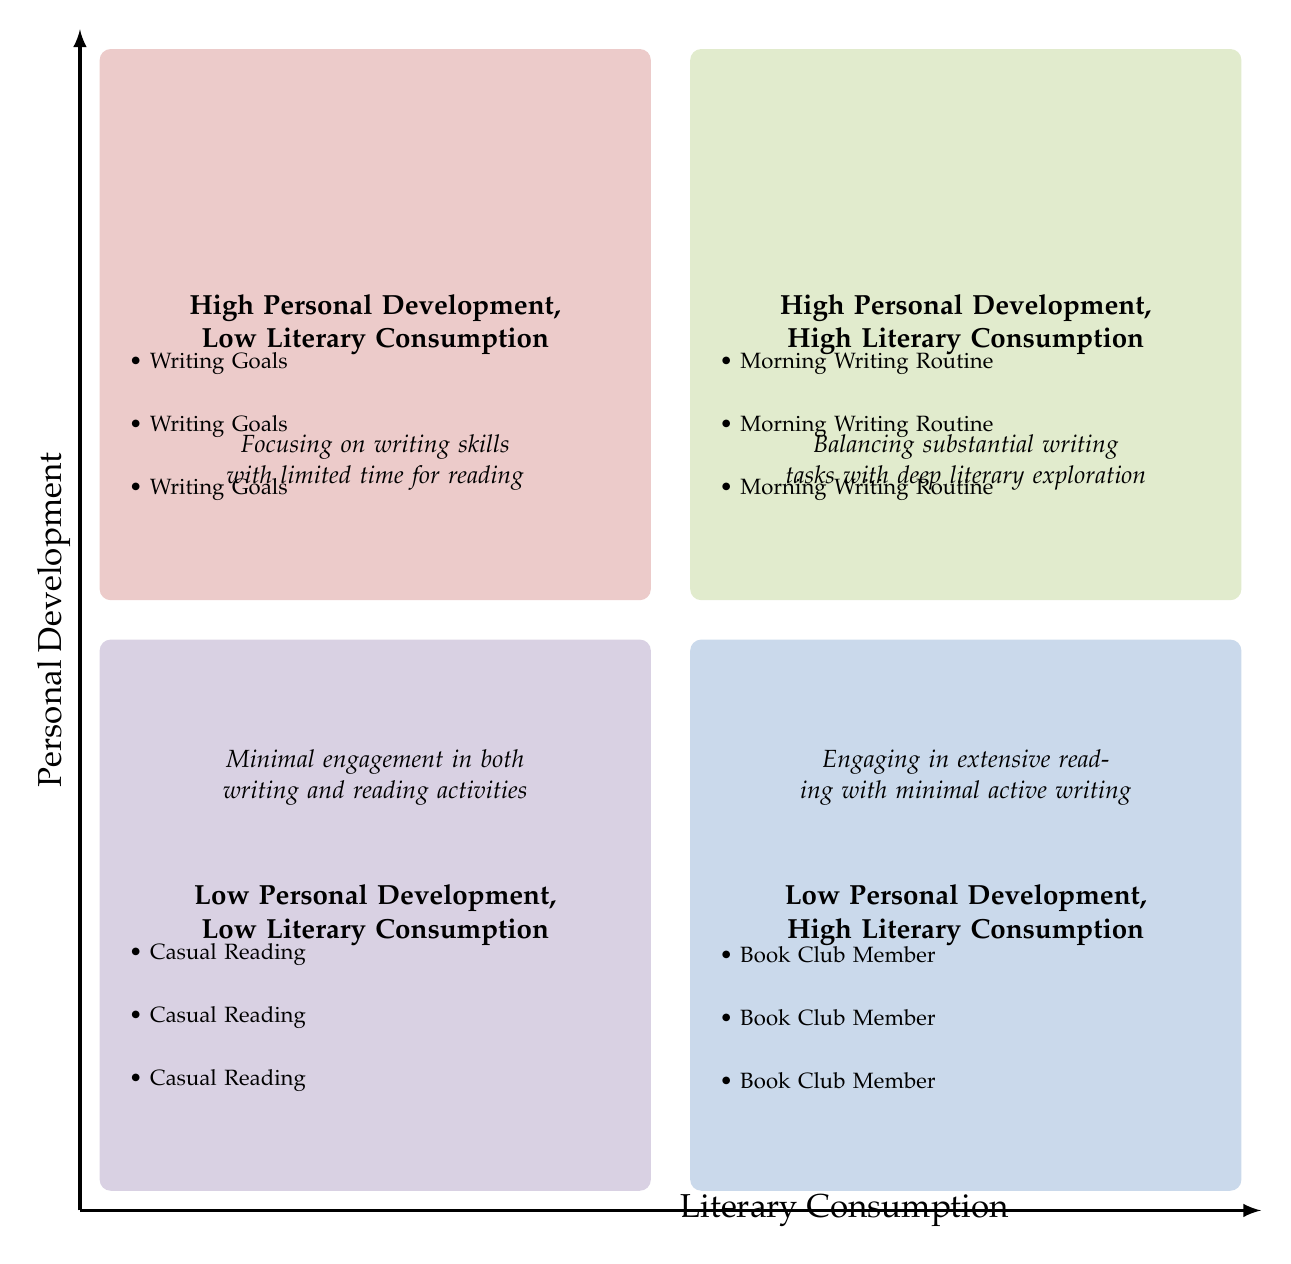What are the titles of the quadrants in the diagram? The diagram consists of four quadrants, each with its own title: High Personal Development, High Literary Consumption; High Personal Development, Low Literary Consumption; Low Personal Development, High Literary Consumption; Low Personal Development, Low Literary Consumption. Each title represents a specific relationship between personal development and literary consumption.
Answer: High Personal Development, High Literary Consumption; High Personal Development, Low Literary Consumption; Low Personal Development, High Literary Consumption; Low Personal Development, Low Literary Consumption Which quadrant has the description "Engaging in extensive reading with minimal active writing"? This description corresponds to the quadrant that is labeled as "Low Personal Development, High Literary Consumption". By identifying the description within the context of the quadrants, we can find its match.
Answer: Low Personal Development, High Literary Consumption How many examples are listed in the "High Personal Development, Low Literary Consumption" quadrant? There are three examples provided in this quadrant. The structure of the diagram shows that each quadrant has a designated number of listed items, and by counting them in this specific quadrant, we find there are precisely three examples listed.
Answer: 3 What is the primary focus of activities in the "Low Personal Development, Low Literary Consumption" quadrant? This quadrant emphasizes minimal engagement in both writing and reading activities. By interpreting the quadrant title and correlating it with the provided examples, we can conclude its primary focus.
Answer: Minimal engagement in both writing and reading activities Which example from the "High Personal Development, High Literary Consumption" quadrant involves daily writing? The example that involves daily writing is "Morning Writing Routine." It is outlined as one of the activities meant to enhance personal development through writing specifically focused on autobiography drafts.
Answer: Morning Writing Routine In which quadrant would you find activities that prioritize writing goals? Activities prioritizing writing goals are found in the "High Personal Development, Low Literary Consumption" quadrant. By analyzing the context of writing goals, we correlate these activities directly with that quadrant's focus on writing while limiting reading time.
Answer: High Personal Development, Low Literary Consumption What color represents the "Low Personal Development, High Literary Consumption" quadrant? The color representing this quadrant is a shade of blue identified through the color coding used in the diagram for visual distinction between the quadrants.
Answer: Blue Which quadrant features the example related to a Noël Coward-themed book club? The example related to a Noël Coward-themed book club is located in the "Low Personal Development, High Literary Consumption" quadrant. By matching the example with the quadrant description, we identify its placement accurately.
Answer: Low Personal Development, High Literary Consumption 